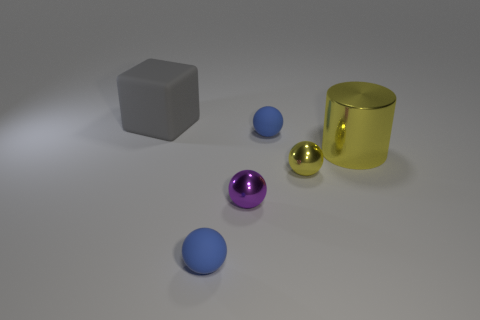Are there any other things that are the same shape as the big gray rubber object?
Ensure brevity in your answer.  No. Is there anything else that is the same size as the gray matte object?
Provide a succinct answer. Yes. How many objects are tiny green shiny balls or big yellow things?
Provide a succinct answer. 1. Are there any other objects that have the same size as the gray thing?
Ensure brevity in your answer.  Yes. What shape is the tiny yellow object?
Ensure brevity in your answer.  Sphere. Is the number of tiny blue matte spheres behind the large cylinder greater than the number of blue matte things right of the purple object?
Your answer should be very brief. No. There is a large object to the right of the large cube; is its color the same as the tiny metallic ball on the left side of the yellow metallic sphere?
Your answer should be compact. No. There is a yellow shiny object that is the same size as the purple metal sphere; what is its shape?
Keep it short and to the point. Sphere. Is there another metallic thing that has the same shape as the tiny yellow shiny object?
Your answer should be compact. Yes. Is the material of the yellow object to the left of the large yellow shiny cylinder the same as the ball that is in front of the purple sphere?
Keep it short and to the point. No. 